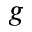<formula> <loc_0><loc_0><loc_500><loc_500>g</formula> 